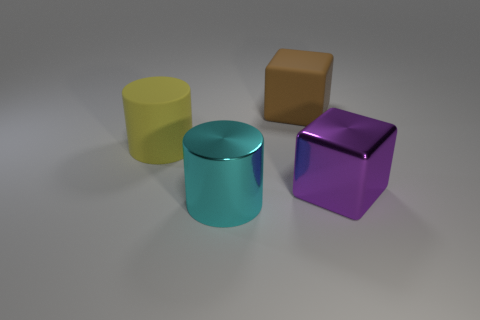Add 2 big gray matte things. How many objects exist? 6 Add 3 big cylinders. How many big cylinders are left? 5 Add 2 big cyan cylinders. How many big cyan cylinders exist? 3 Subtract 0 purple cylinders. How many objects are left? 4 Subtract all large metal blocks. Subtract all large metallic blocks. How many objects are left? 2 